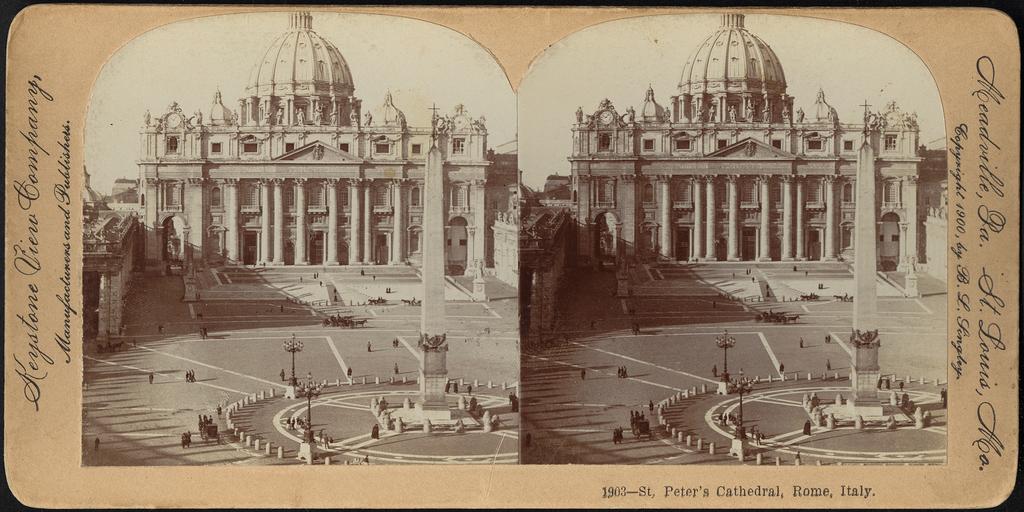What is the name of this cathedral?
Your answer should be compact. St peters. What country is the cathedral in?
Provide a short and direct response. Italy. 